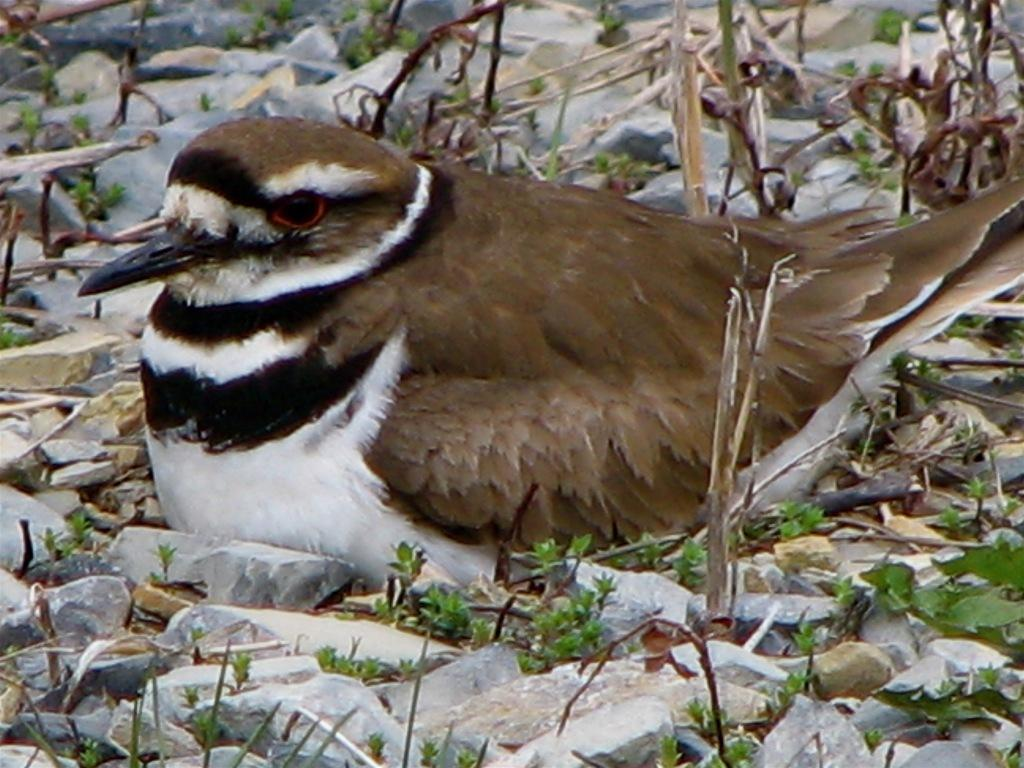What type of animal can be seen in the image? There is a bird in the image. What other elements are present in the image besides the bird? There are plants and stones in the image. What shape is the tub in the image? There is no tub present in the image. 